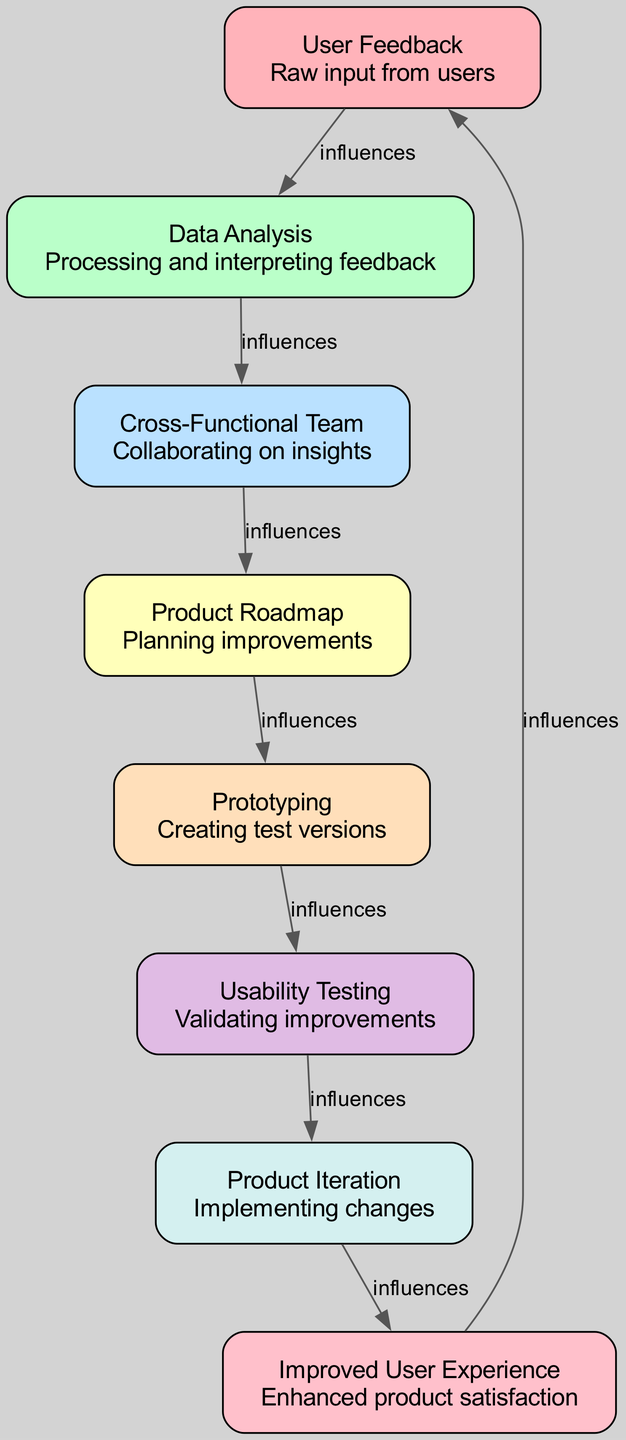What is the first node in the diagram? The first node mentioned in the diagram is "User Feedback," which represents the initial point of input from users.
Answer: User Feedback How many elements are there in total? By counting the listed nodes in the diagram, there are eight elements representing different stages in the user feedback process.
Answer: Eight What does "Product Iteration" influence? According to the flow of the diagram, "Product Iteration" directly influences "Improved User Experience," indicating it contributes to enhancing user satisfaction.
Answer: Improved User Experience Which node follows "Usability Testing"? The node that follows "Usability Testing" in the flow of the diagram is "Product Iteration," signifying the next step after validating improvements.
Answer: Product Iteration What is the relationship between "Cross-Functional Team" and "Product Roadmap"? The "Cross-Functional Team" influences the "Product Roadmap" in the diagram, showing that the team collaborates to inform the planning of product improvements.
Answer: influences How does "User Feedback" connect to "Improved User Experience"? "User Feedback" indirectly influences "Improved User Experience" through a series of connections: it is analyzed to derive insights, which then inform the team's collaboration, leading to product planning, prototyping, testing, and ultimately, improvements that enhance user experience.
Answer: indirectly What is the role of "Prototyping" in the chain? "Prototyping" plays the role of creating test versions of products that emerge from planning and analysis, acting as a critical step before validating improvements through usability testing.
Answer: Creating test versions What is the last node presented in the diagram? The last node in the diagram is "User Feedback," which completes the loop by indicating that improved experiences lead to new feedback from users for further iterations.
Answer: User Feedback 